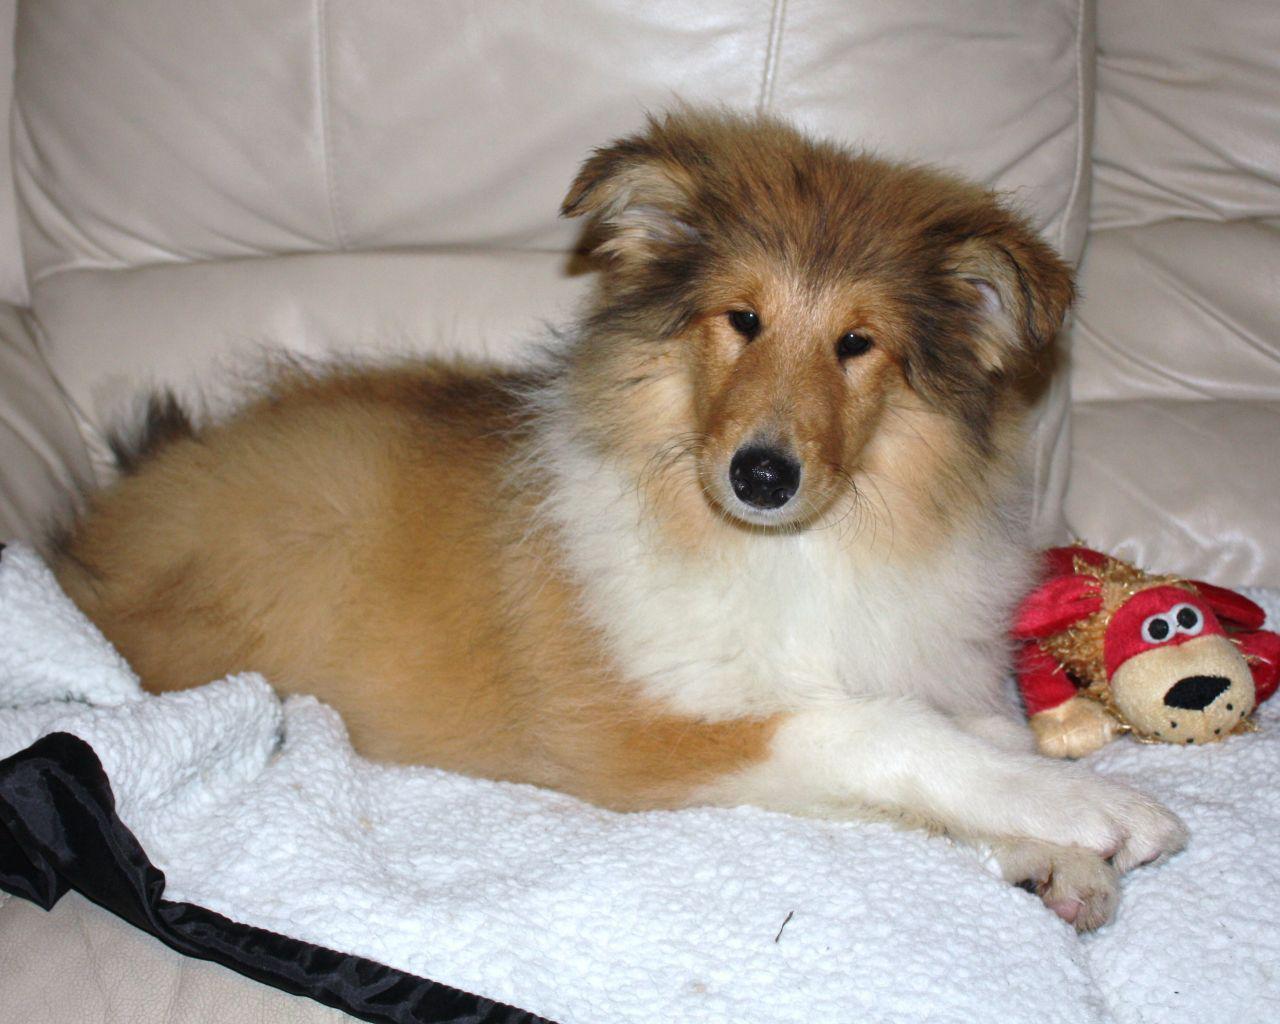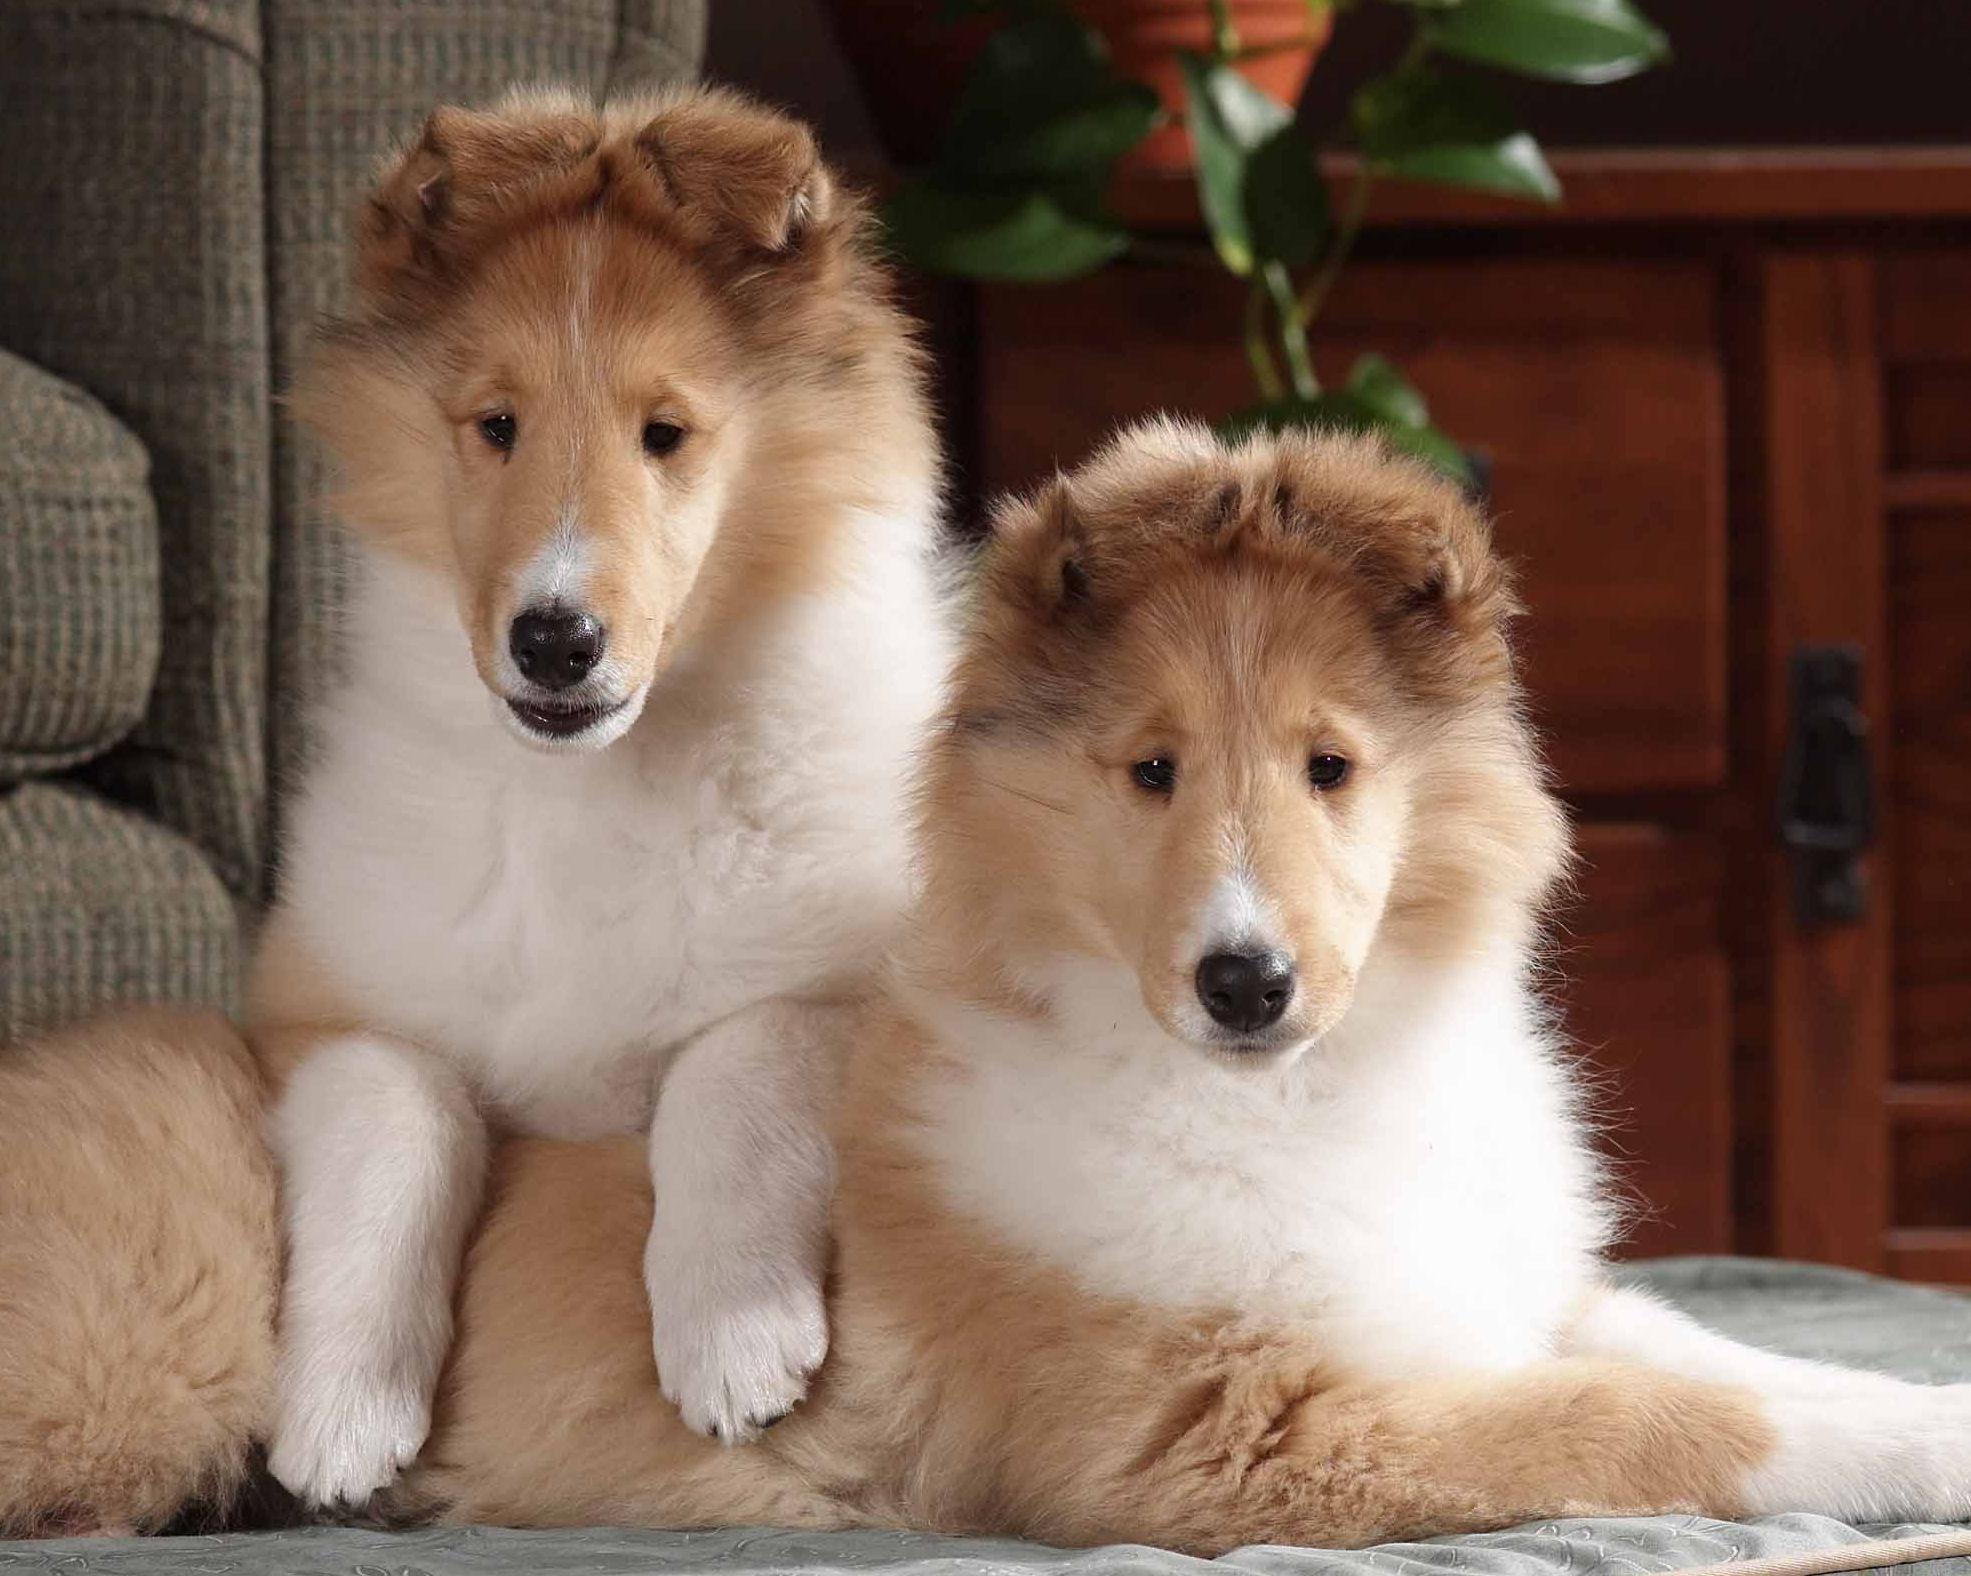The first image is the image on the left, the second image is the image on the right. Evaluate the accuracy of this statement regarding the images: "There are three dogs in total.". Is it true? Answer yes or no. Yes. 